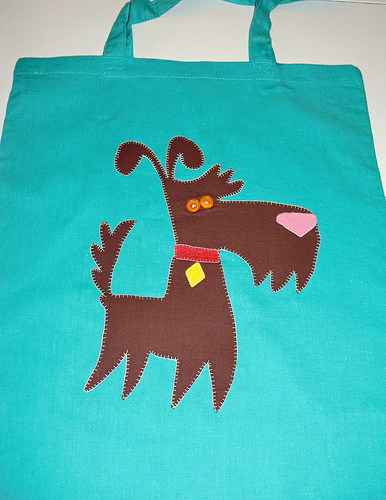<image>
Can you confirm if the dog is in the bag? No. The dog is not contained within the bag. These objects have a different spatial relationship. 